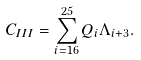Convert formula to latex. <formula><loc_0><loc_0><loc_500><loc_500>C _ { I I I } = \sum _ { i = 1 6 } ^ { 2 5 } Q _ { i } \Lambda _ { i + 3 } .</formula> 